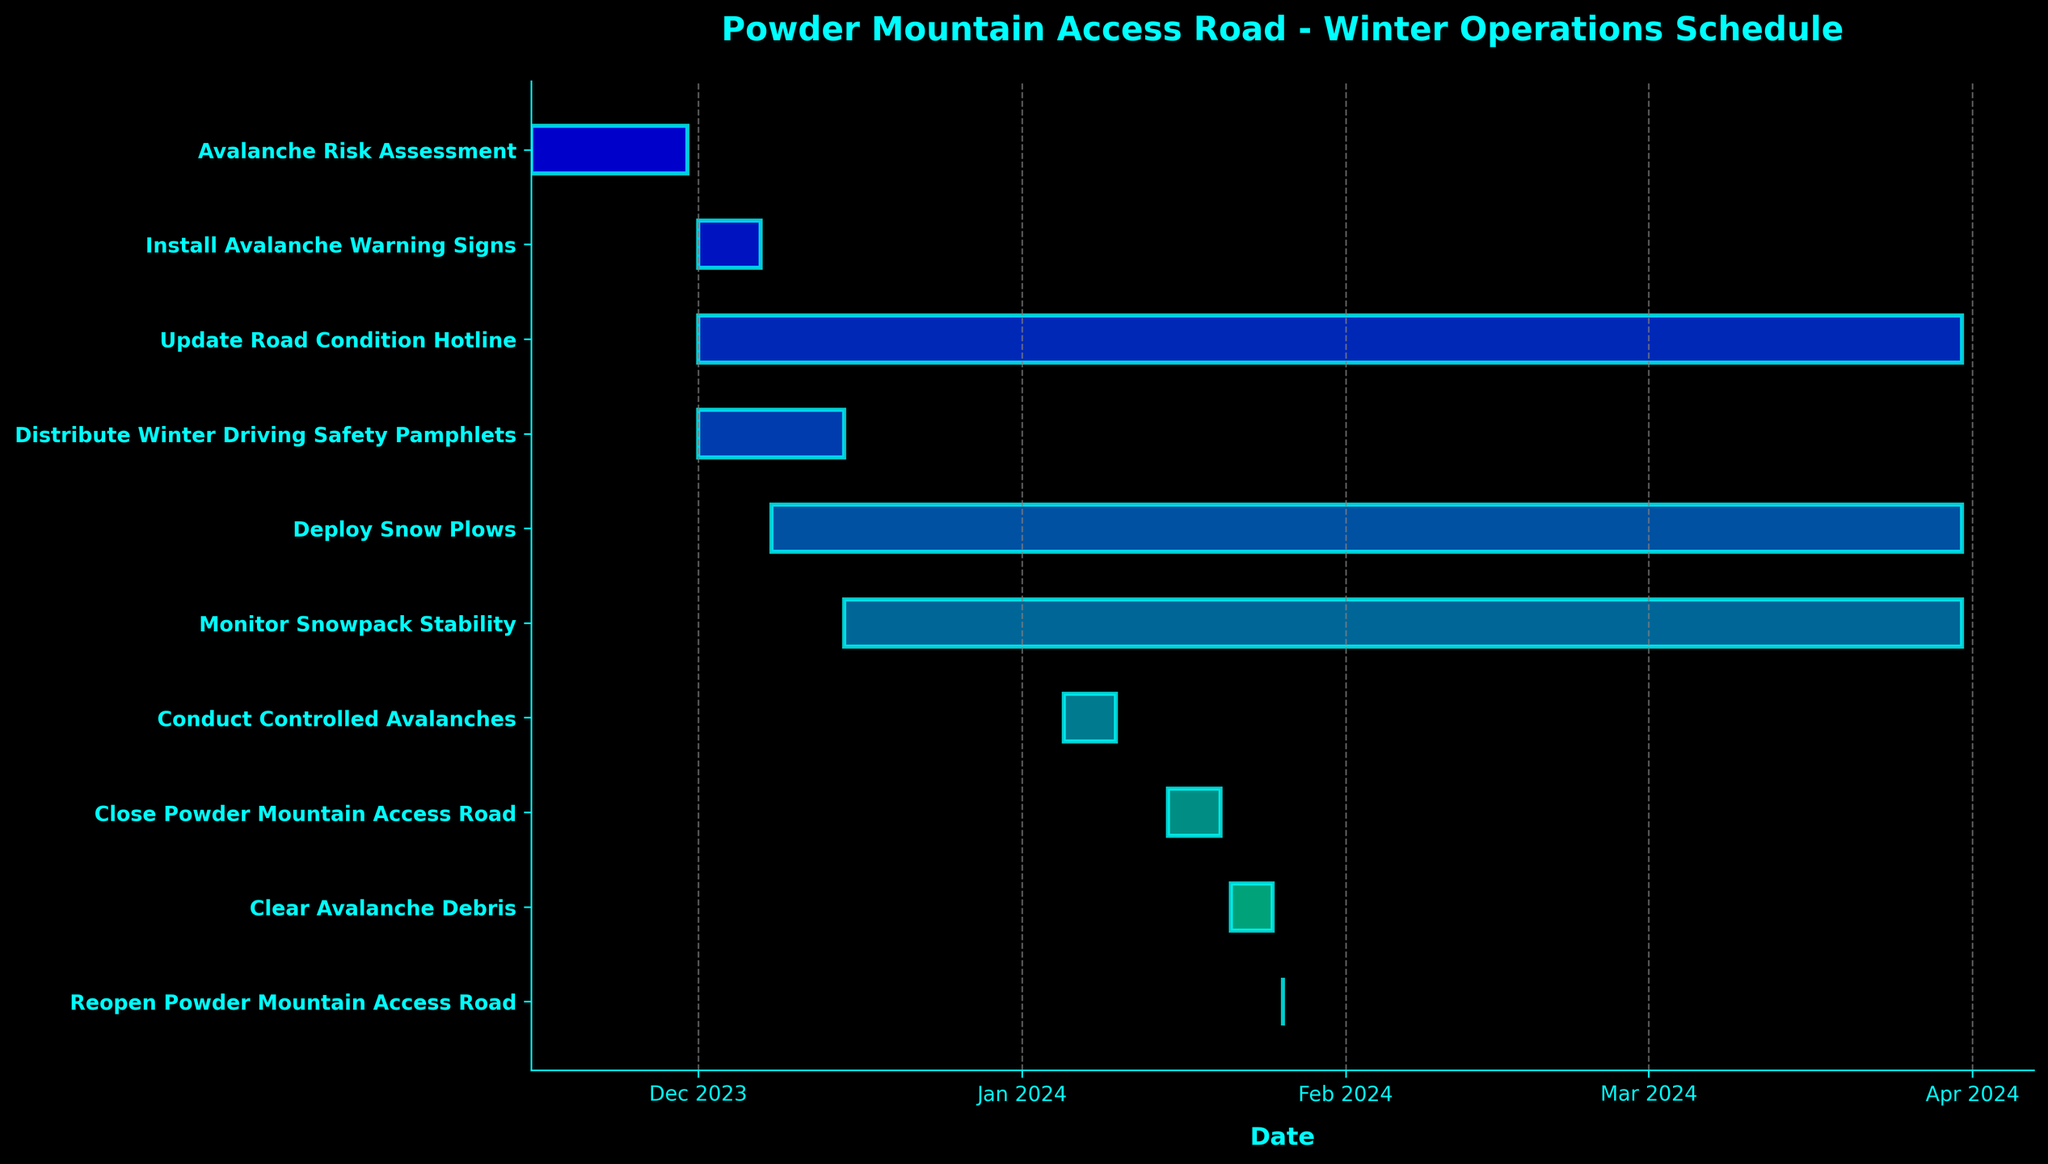What's the title of the Gantt chart? The title is usually displayed at the top of the chart, indicating the main theme or focus of the data visualized. In this case, the title located at the top center is "Powder Mountain Access Road - Winter Operations Schedule".
Answer: Powder Mountain Access Road - Winter Operations Schedule Which task has the shortest duration? We need to compare the lengths of the horizontal bars representing each task. The shortest bar corresponds to "Reopen Powder Mountain Access Road", which lasts for just one day.
Answer: Reopen Powder Mountain Access Road When does the task "Deploy Snow Plows" start and end? We check the horizontal bar corresponding to "Deploy Snow Plows" and read the start and end dates marked on the timeline. This task starts on 2023-12-08 and ends on 2024-03-31.
Answer: 2023-12-08 to 2024-03-31 How many tasks start in December 2023? We count the number of horizontal bars that have their starting point in December 2023 by checking the start dates. There are five such tasks: "Install Avalanche Warning Signs", "Deploy Snow Plows", "Monitor Snowpack Stability", "Update Road Condition Hotline", and "Distribute Winter Driving Safety Pamphlets".
Answer: 5 tasks Which tasks overlap with "Conduct Controlled Avalanches"? We need to identify horizontal bars that span the date range of "Conduct Controlled Avalanches", which is from 2024-01-05 to 2024-01-10. The tasks that span the same date range are "Deploy Snow Plows" and "Monitor Snowpack Stability".
Answer: Deploy Snow Plows, Monitor Snowpack Stability What is the duration of "Clear Avalanche Debris"? To find the duration, we calculate the difference in days between the start and end dates of "Clear Avalanche Debris", which are 2024-01-21 and 2024-01-25. The duration is (2024-01-25 - 2024-01-21) = 4 days.
Answer: 4 days Which task has the longest duration? We need to look for the longest horizontal bar representing the tasks. The task "Deploy Snow Plows" spans from 2023-12-08 to 2024-03-31, making it the longest in duration.
Answer: Deploy Snow Plows Which task completes first after the beginning of 2024? We check for the task that ends soonest after the start of 2024. Among the tasks starting in 2024, "Conduct Controlled Avalanches" ends on 2024-01-10, which is the earliest end date.
Answer: Conduct Controlled Avalanches Which two tasks are the closest to each other in the timeline? We need to compare the start and end dates of adjacent tasks to find the smallest gap between them. Comparing adjacent tasks, "Clear Avalanche Debris" ends on 2024-01-25 and "Reopen Powder Mountain Access Road" starts on 2024-01-26, making them the closest.
Answer: Clear Avalanche Debris and Reopen Powder Mountain Access Road 